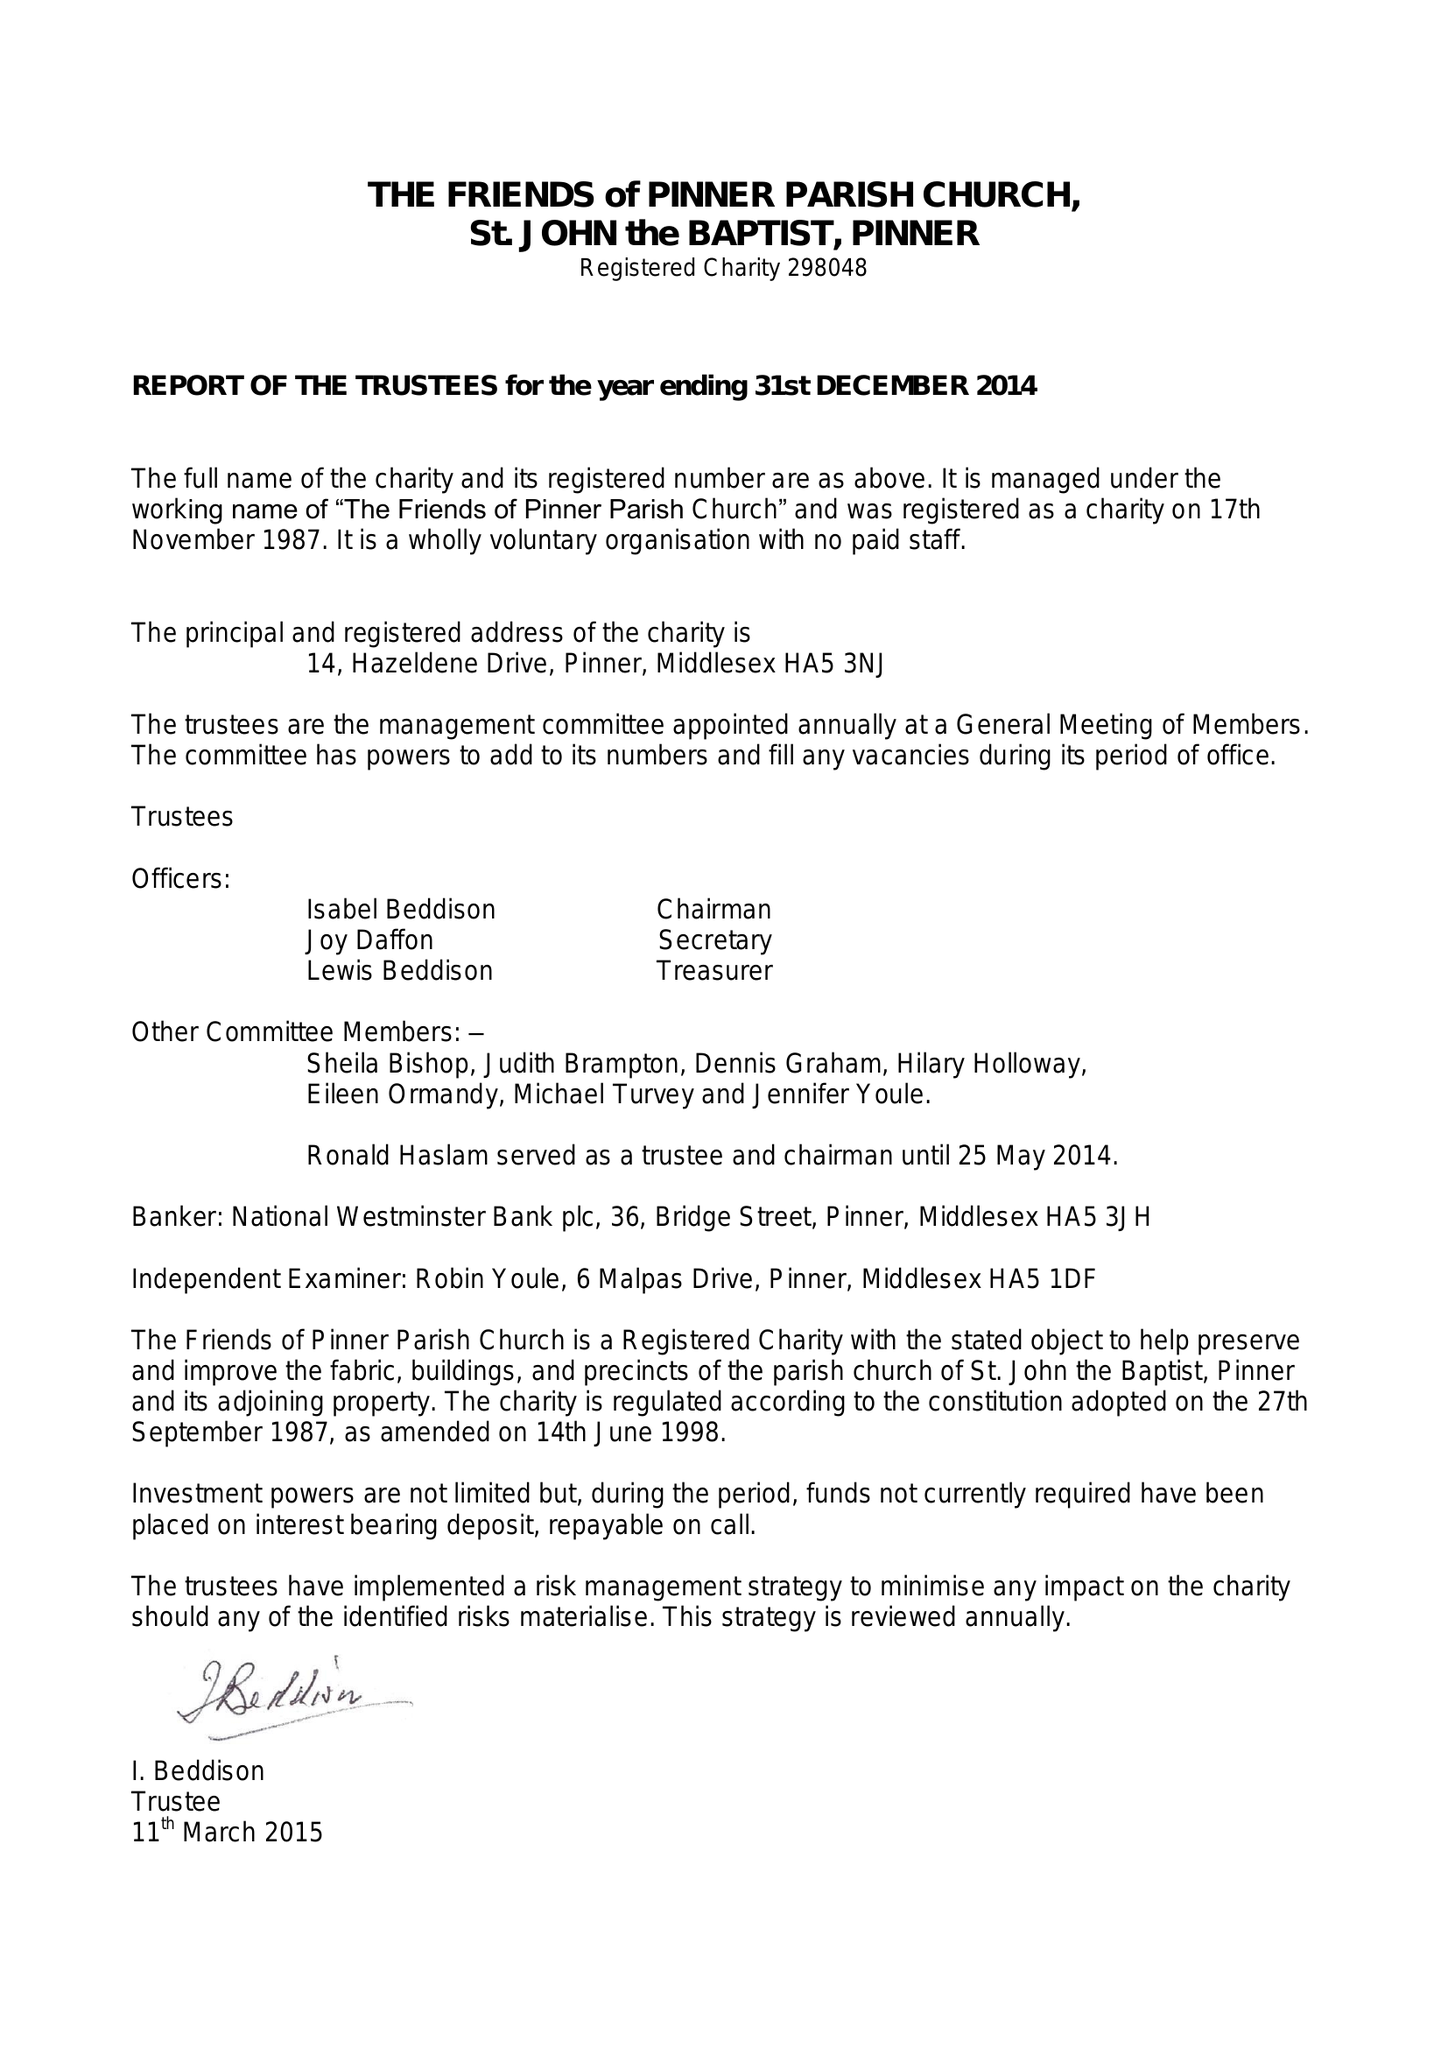What is the value for the income_annually_in_british_pounds?
Answer the question using a single word or phrase. 42271.00 